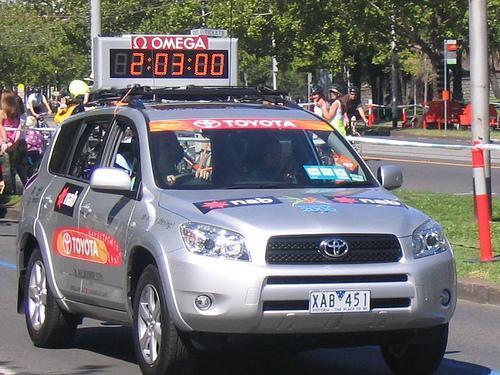How many cars are in the picture?
Give a very brief answer. 1. How many clocks can be seen?
Give a very brief answer. 1. 